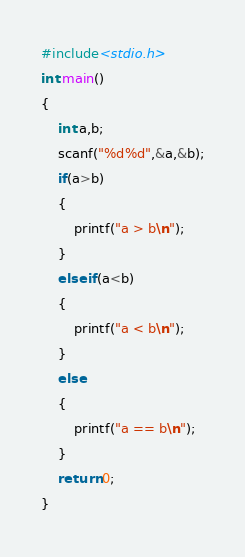<code> <loc_0><loc_0><loc_500><loc_500><_C_>#include<stdio.h>
int main()
{
    int a,b;
    scanf("%d%d",&a,&b);
    if(a>b)
    {
        printf("a > b\n");
    }
    else if(a<b)
    {
        printf("a < b\n");
    }
    else
    {
        printf("a == b\n");
    }
    return 0;
}

</code> 